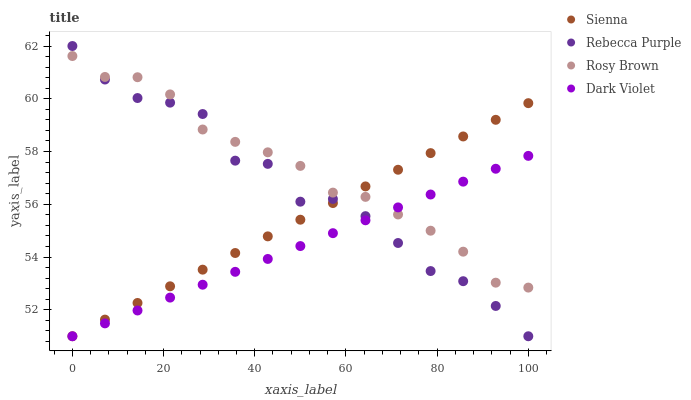Does Dark Violet have the minimum area under the curve?
Answer yes or no. Yes. Does Rosy Brown have the maximum area under the curve?
Answer yes or no. Yes. Does Rebecca Purple have the minimum area under the curve?
Answer yes or no. No. Does Rebecca Purple have the maximum area under the curve?
Answer yes or no. No. Is Dark Violet the smoothest?
Answer yes or no. Yes. Is Rebecca Purple the roughest?
Answer yes or no. Yes. Is Rosy Brown the smoothest?
Answer yes or no. No. Is Rosy Brown the roughest?
Answer yes or no. No. Does Sienna have the lowest value?
Answer yes or no. Yes. Does Rosy Brown have the lowest value?
Answer yes or no. No. Does Rebecca Purple have the highest value?
Answer yes or no. Yes. Does Rosy Brown have the highest value?
Answer yes or no. No. Does Sienna intersect Rosy Brown?
Answer yes or no. Yes. Is Sienna less than Rosy Brown?
Answer yes or no. No. Is Sienna greater than Rosy Brown?
Answer yes or no. No. 